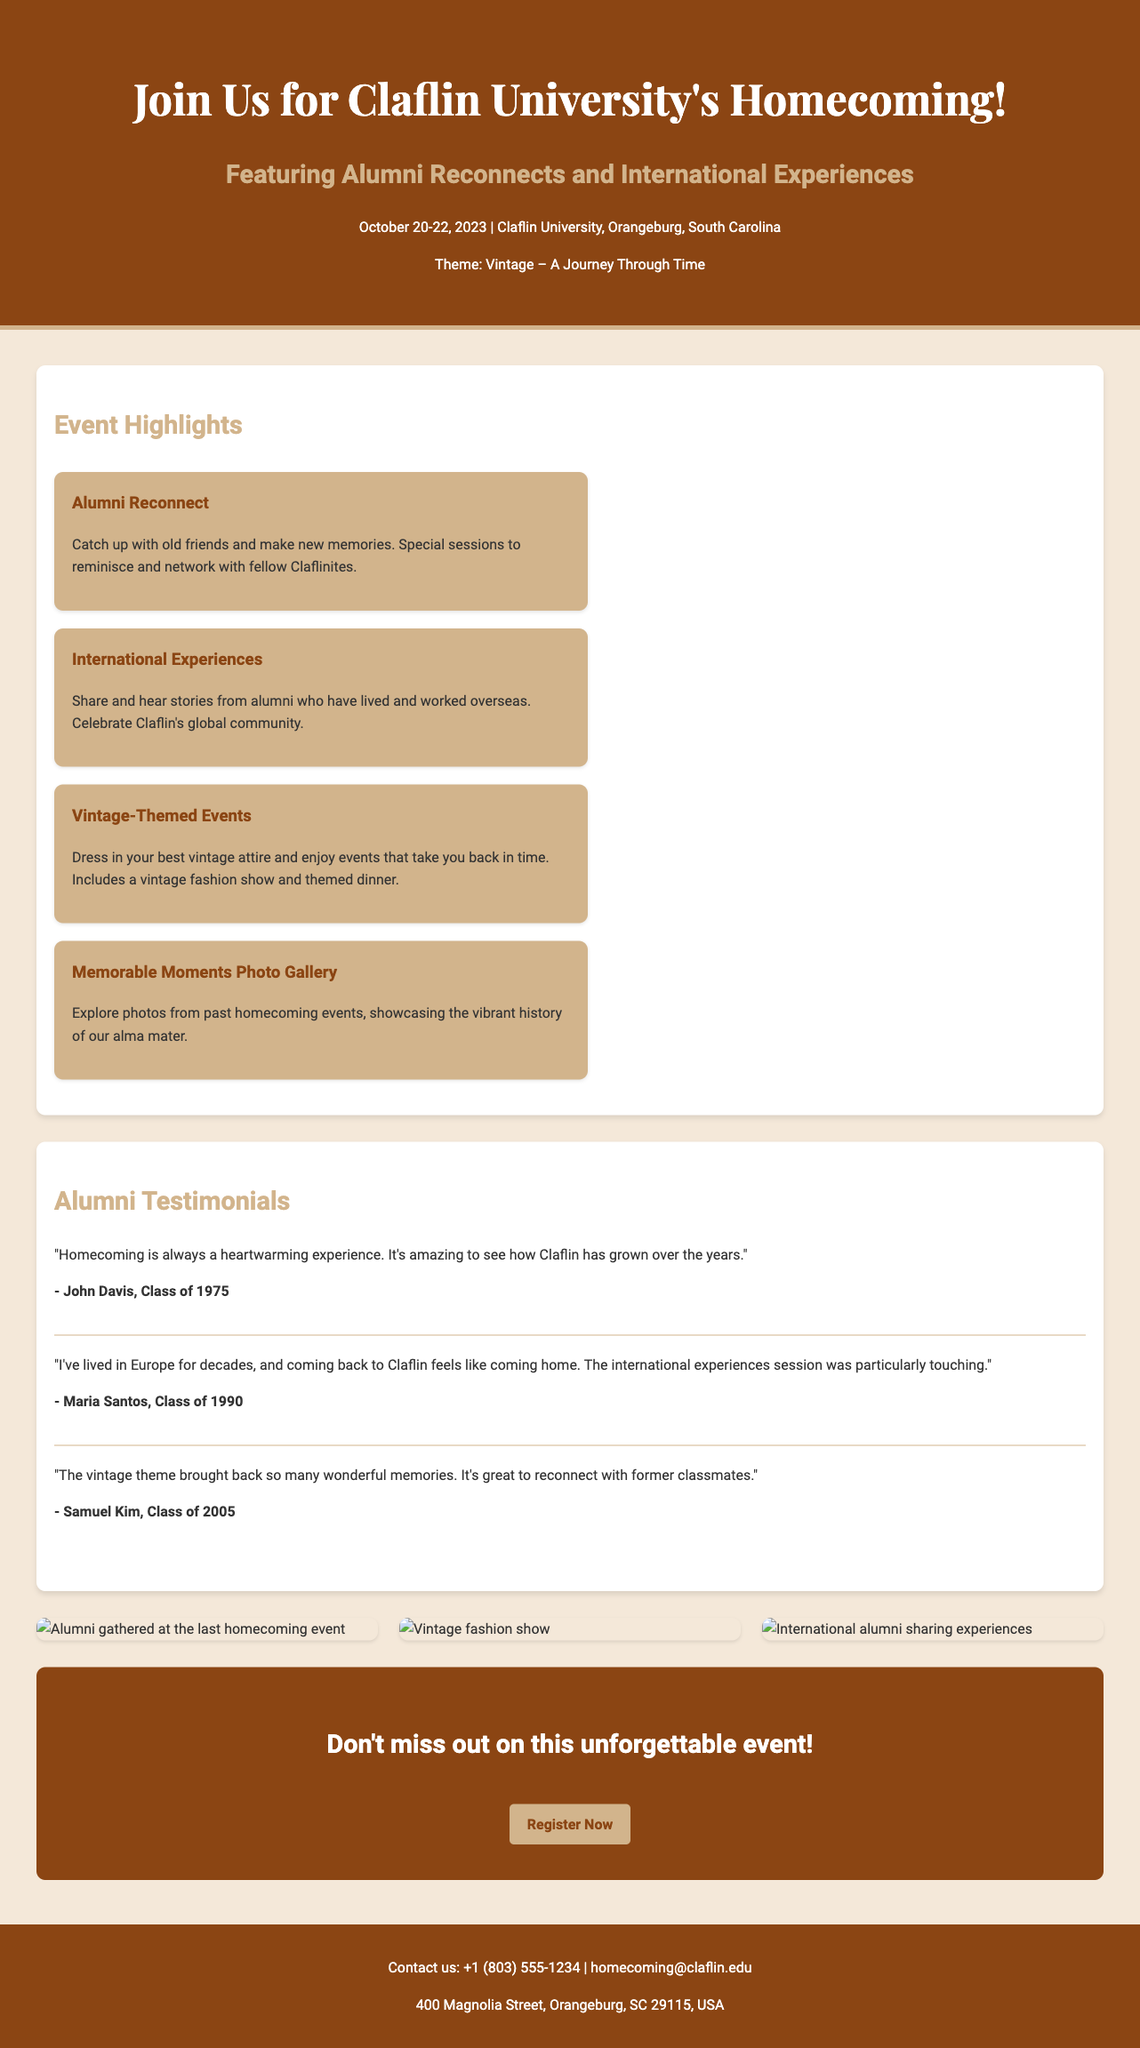What are the dates of the Claflin University Homecoming event? The dates of the event are explicitly mentioned in the advertisement as October 20-22, 2023.
Answer: October 20-22, 2023 What is the theme of the Homecoming event? The theme of the Homecoming event is mentioned in bold letters as "Vintage – A Journey Through Time."
Answer: Vintage – A Journey Through Time Who is one of the alumni who provided a testimonial? The document lists testimonials from various alumni, including John Davis from the Class of 1975.
Answer: John Davis What specific session is highlighted for alumni living overseas? The event highlights "International Experiences" as a session for alumni to share their stories from overseas.
Answer: International Experiences How many highlights are mentioned in the event details? The event details section lists four distinct highlights related to different aspects of the Homecoming event.
Answer: Four What is one type of activity mentioned in the Vintage-Themed Events? The advertisement mentions a vintage fashion show as one of the activities in the Vintage-Themed Events.
Answer: Vintage fashion show What is the call to action at the end of the advertisement? The call to action invites readers to "Register Now," encouraging them to sign up for the event.
Answer: Register Now What is the contact email provided in the footer? The footer of the advertisement includes a contact email, which is specifically stated as homecoming@claflin.edu.
Answer: homecoming@claflin.edu How many testimonials are present in the document? The document contains three testimonials from different alumni sharing their experiences about Homecoming.
Answer: Three 